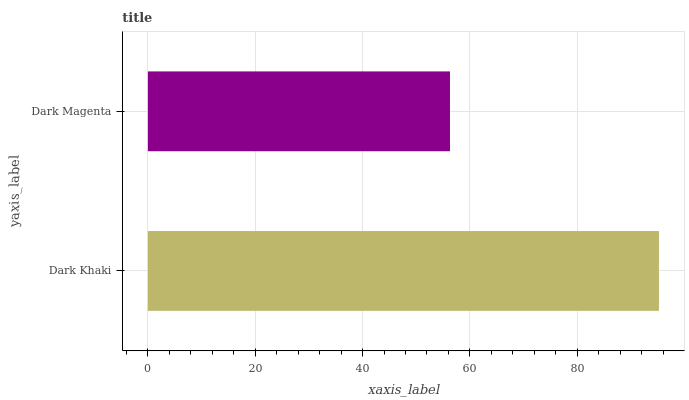Is Dark Magenta the minimum?
Answer yes or no. Yes. Is Dark Khaki the maximum?
Answer yes or no. Yes. Is Dark Magenta the maximum?
Answer yes or no. No. Is Dark Khaki greater than Dark Magenta?
Answer yes or no. Yes. Is Dark Magenta less than Dark Khaki?
Answer yes or no. Yes. Is Dark Magenta greater than Dark Khaki?
Answer yes or no. No. Is Dark Khaki less than Dark Magenta?
Answer yes or no. No. Is Dark Khaki the high median?
Answer yes or no. Yes. Is Dark Magenta the low median?
Answer yes or no. Yes. Is Dark Magenta the high median?
Answer yes or no. No. Is Dark Khaki the low median?
Answer yes or no. No. 